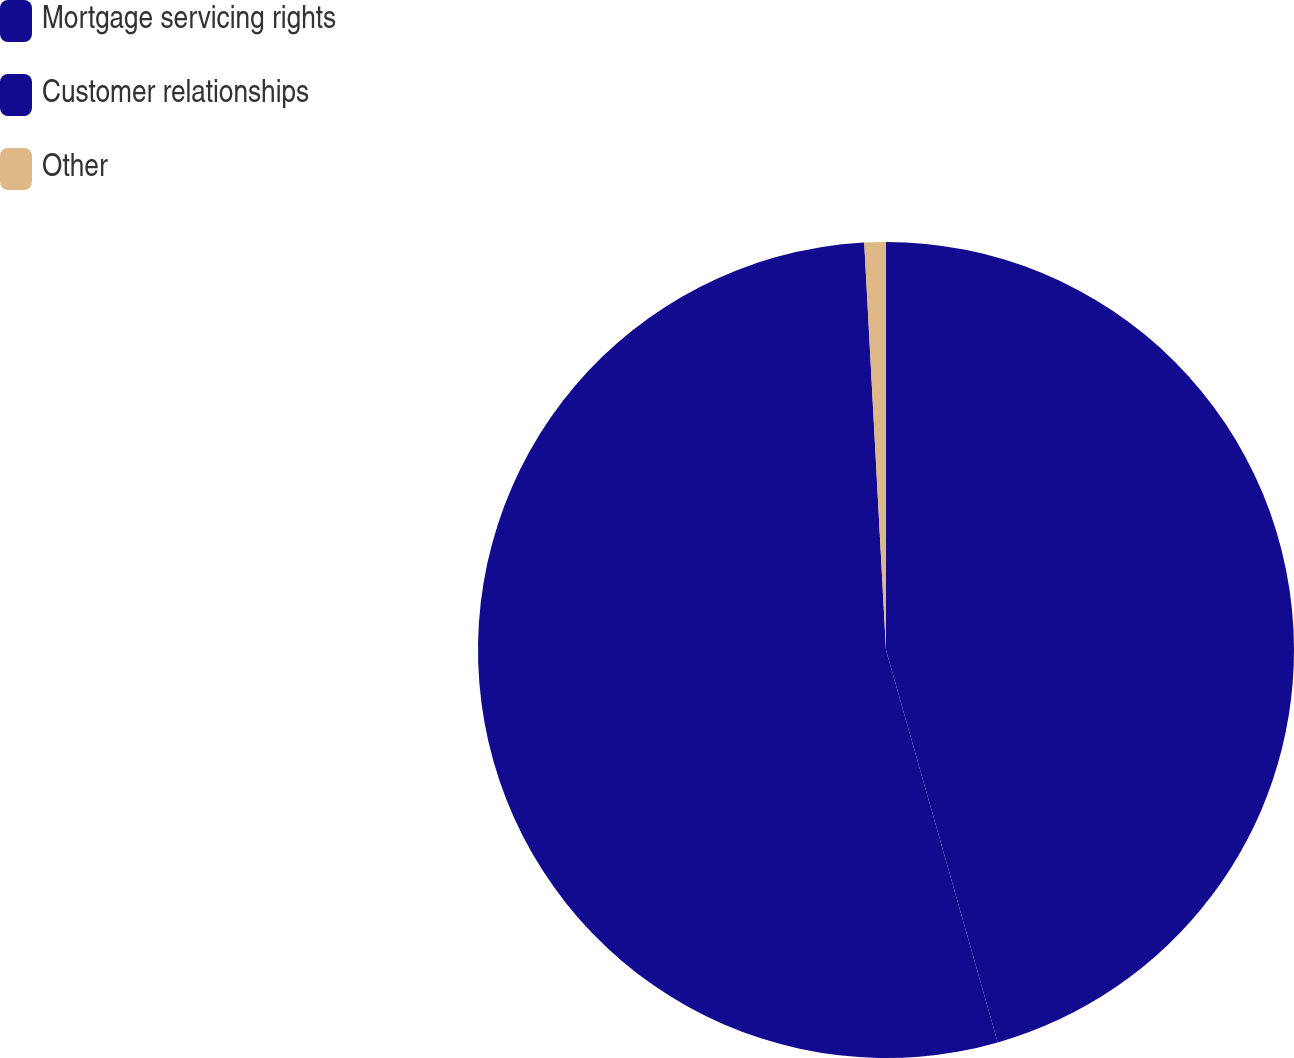<chart> <loc_0><loc_0><loc_500><loc_500><pie_chart><fcel>Mortgage servicing rights<fcel>Customer relationships<fcel>Other<nl><fcel>45.58%<fcel>53.56%<fcel>0.85%<nl></chart> 